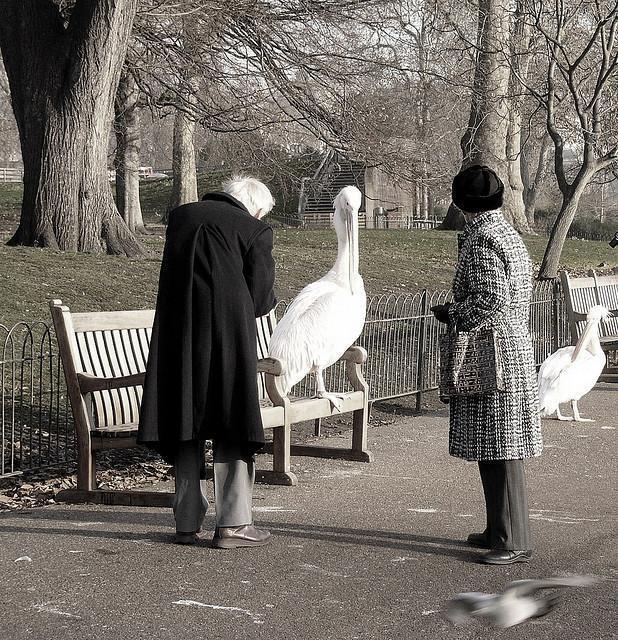How many animals are in this photo?
Give a very brief answer. 2. How many birds can you see?
Give a very brief answer. 3. How many people are there?
Give a very brief answer. 2. How many benches can you see?
Give a very brief answer. 2. 